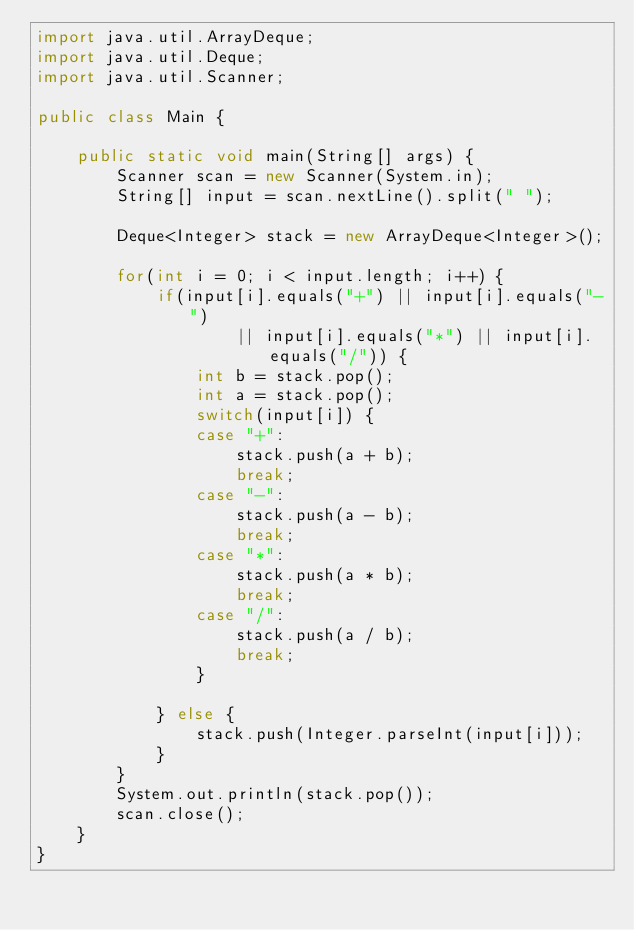Convert code to text. <code><loc_0><loc_0><loc_500><loc_500><_Java_>import java.util.ArrayDeque;
import java.util.Deque;
import java.util.Scanner;

public class Main {

	public static void main(String[] args) {
		Scanner scan = new Scanner(System.in);
		String[] input = scan.nextLine().split(" ");

		Deque<Integer> stack = new ArrayDeque<Integer>();

		for(int i = 0; i < input.length; i++) {
			if(input[i].equals("+") || input[i].equals("-")
					|| input[i].equals("*") || input[i].equals("/")) {
				int b = stack.pop();
				int a = stack.pop();
				switch(input[i]) {
				case "+":
					stack.push(a + b);
					break;
				case "-":
					stack.push(a - b);
					break;
				case "*":
					stack.push(a * b);
					break;
				case "/":
					stack.push(a / b);
					break;
				}

			} else {
				stack.push(Integer.parseInt(input[i]));
			}
		}
		System.out.println(stack.pop());
		scan.close();
	}
}
</code> 